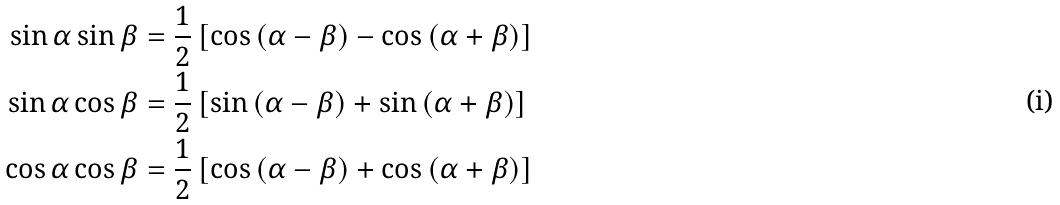Convert formula to latex. <formula><loc_0><loc_0><loc_500><loc_500>\sin \alpha \sin \beta & = \frac { 1 } { 2 } \left [ \cos \left ( \alpha - \beta \right ) - \cos \left ( \alpha + \beta \right ) \right ] \\ \sin \alpha \cos \beta & = \frac { 1 } { 2 } \left [ \sin \left ( \alpha - \beta \right ) + \sin \left ( \alpha + \beta \right ) \right ] \\ \cos \alpha \cos \beta & = \frac { 1 } { 2 } \left [ \cos \left ( \alpha - \beta \right ) + \cos \left ( \alpha + \beta \right ) \right ]</formula> 